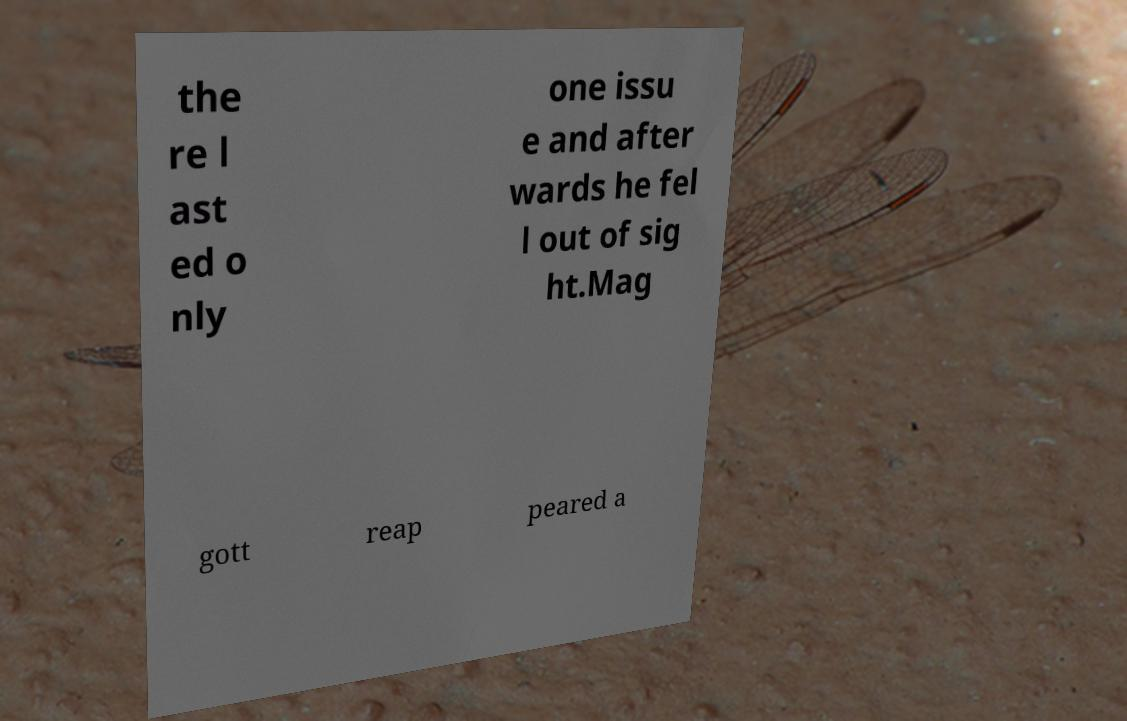Please identify and transcribe the text found in this image. the re l ast ed o nly one issu e and after wards he fel l out of sig ht.Mag gott reap peared a 